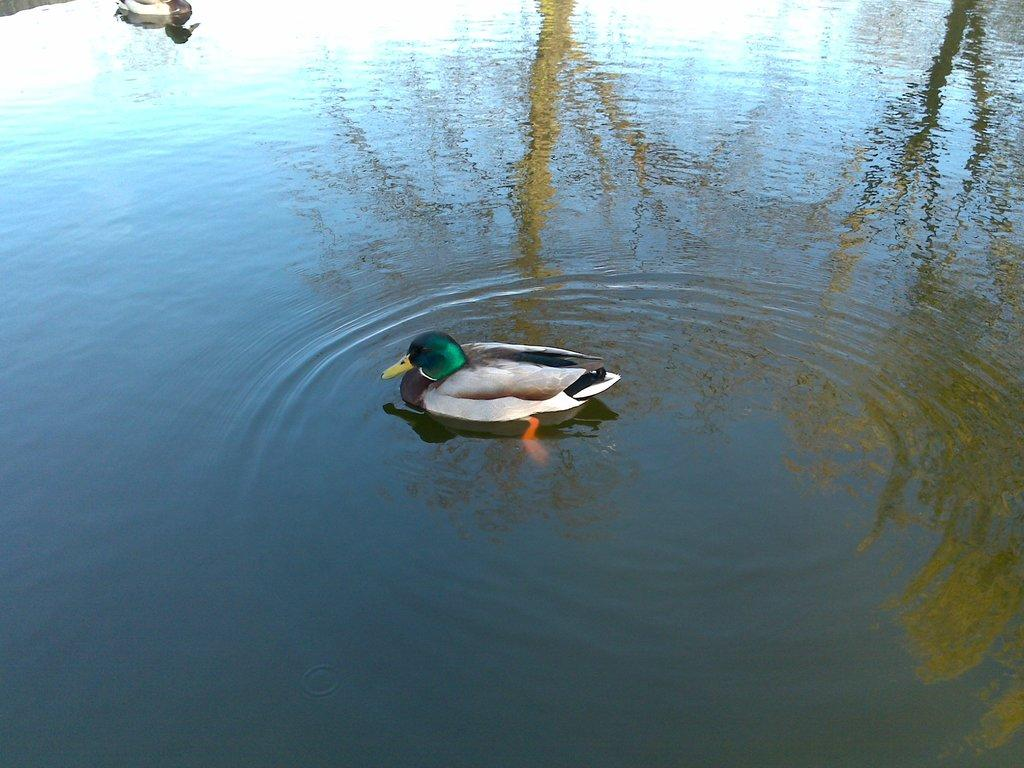What type of animals can be seen in the image? Birds can be seen in the image. What is the primary element in which the birds are situated? The birds are situated in water. What type of arch can be seen in the image? There is no arch present in the image; it features birds in the water. What type of table can be seen in the image? There is no table present in the image. What type of love can be seen expressed between the birds in the image? There is no indication of love or any emotions between the birds in the image, as they are simply situated in the water. 